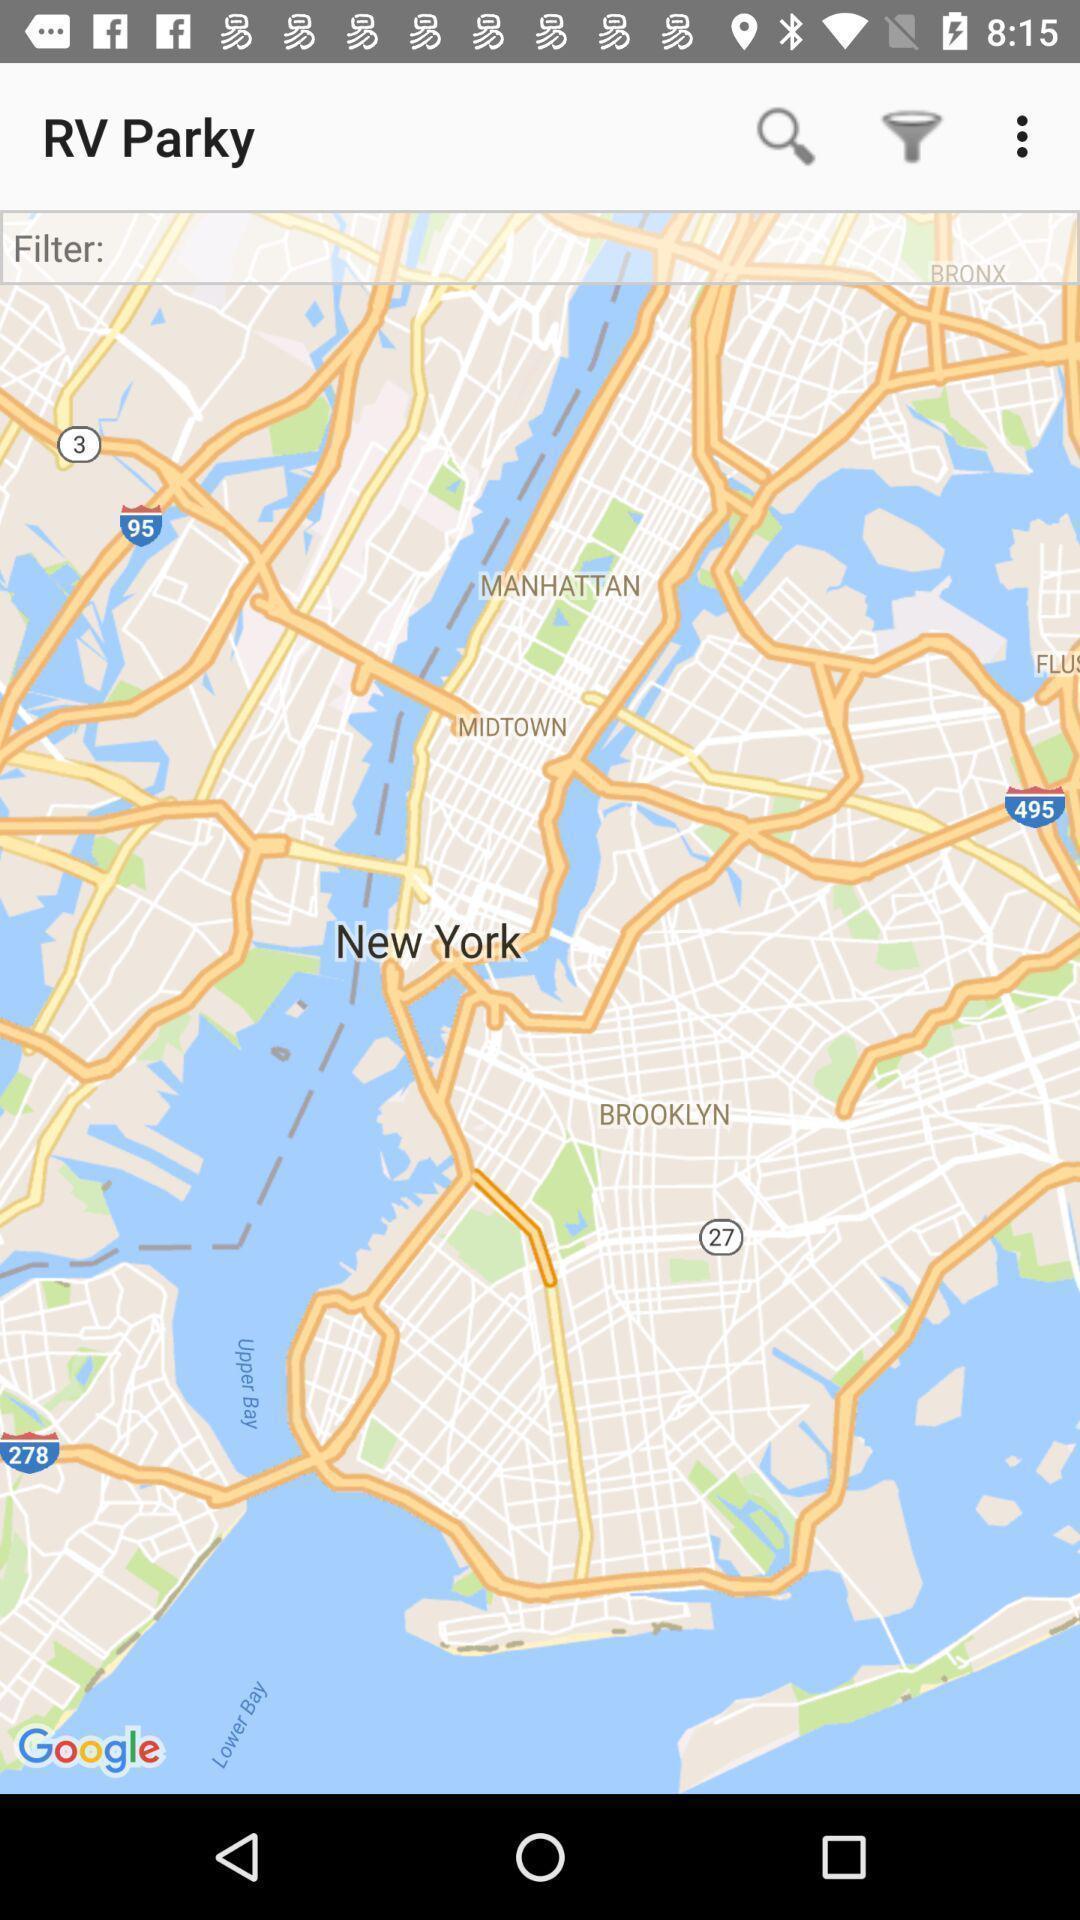Give me a narrative description of this picture. View of the map. 